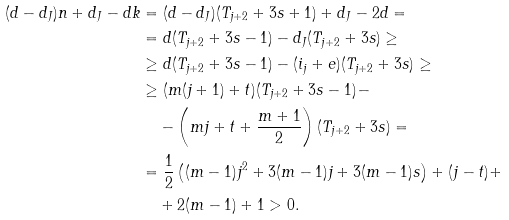<formula> <loc_0><loc_0><loc_500><loc_500>( d - d _ { J } ) n + d _ { J } - d k & = ( d - d _ { J } ) ( T _ { j + 2 } + 3 s + 1 ) + d _ { J } - 2 d = \\ & = d ( T _ { j + 2 } + 3 s - 1 ) - d _ { J } ( T _ { j + 2 } + 3 s ) \geq \\ & \geq d ( T _ { j + 2 } + 3 s - 1 ) - ( i _ { j } + e ) ( T _ { j + 2 } + 3 s ) \geq \\ & \geq ( m ( j + 1 ) + t ) ( T _ { j + 2 } + 3 s - 1 ) - \\ & \quad - \left ( m j + t + \frac { m + 1 } { 2 } \right ) ( T _ { j + 2 } + 3 s ) = \\ & = \frac { 1 } { 2 } \left ( ( m - 1 ) j ^ { 2 } + 3 ( m - 1 ) j + 3 ( m - 1 ) s \right ) + ( j - t ) + \\ & \quad + 2 ( m - 1 ) + 1 > 0 .</formula> 